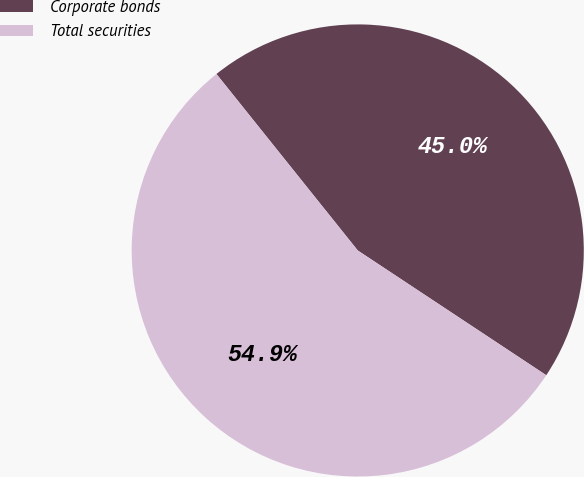Convert chart to OTSL. <chart><loc_0><loc_0><loc_500><loc_500><pie_chart><fcel>Corporate bonds<fcel>Total securities<nl><fcel>45.05%<fcel>54.95%<nl></chart> 